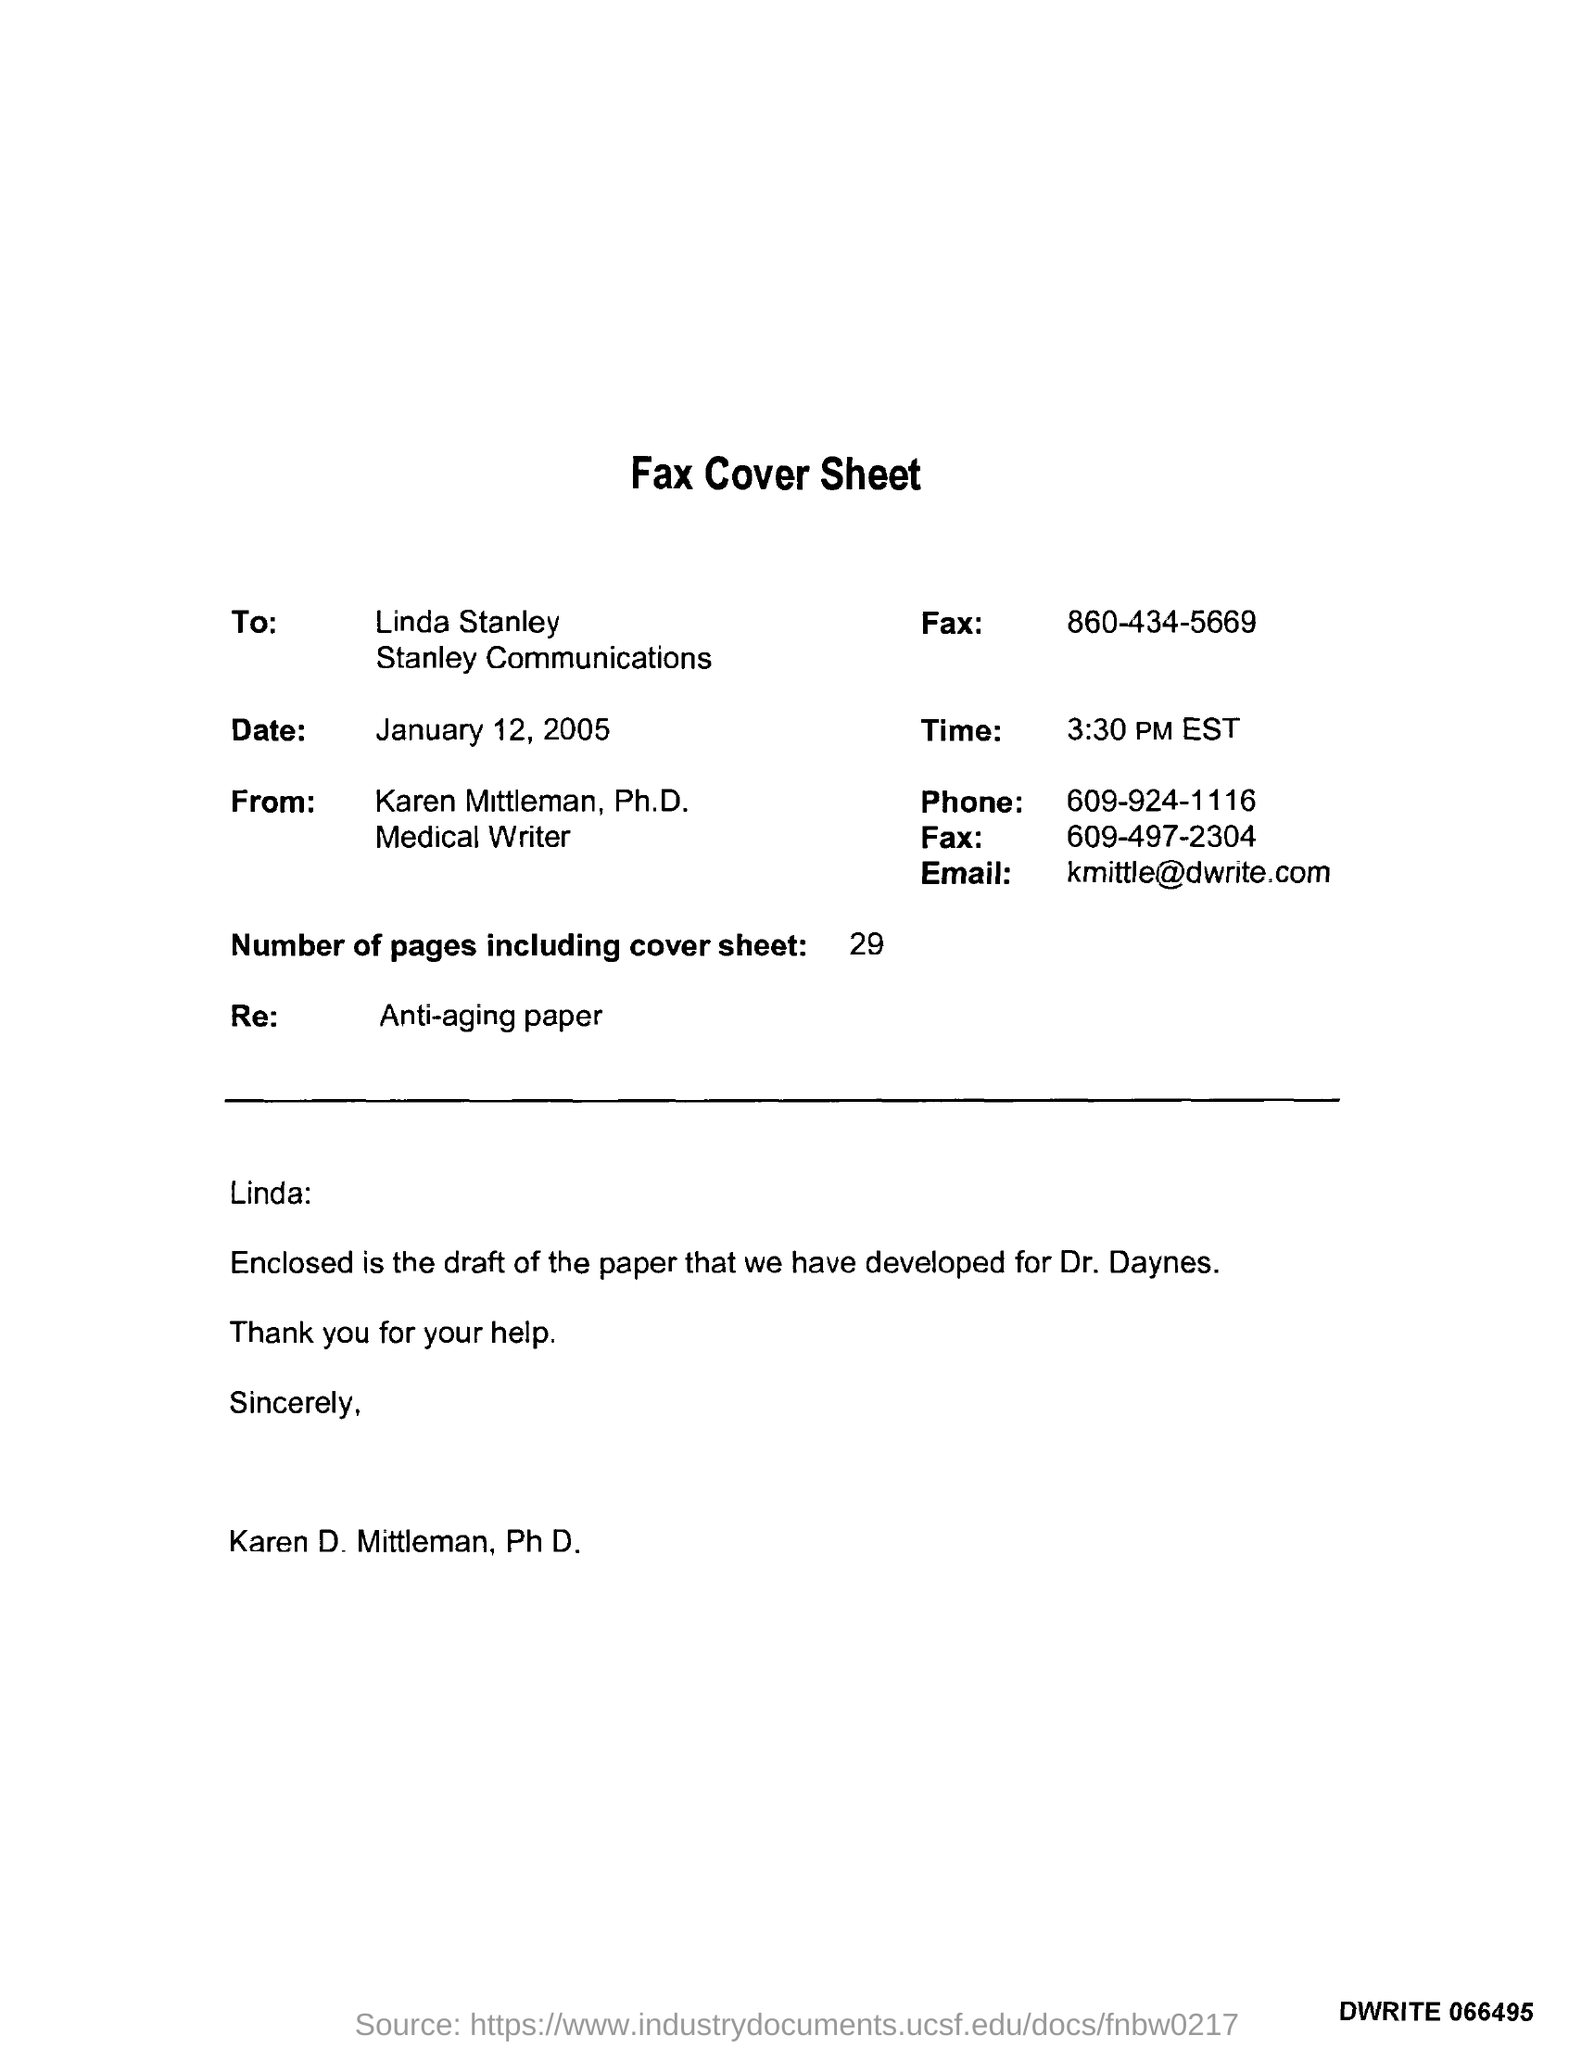To whom this letter was written ?
Your response must be concise. Linda stanley. What is the date mentioned in the fax cover sheet ?
Keep it short and to the point. January 12 , 2005. From whom this fax message was delivered ?
Offer a terse response. Karen mittleman, ph.d. What is the time mentioned in the given fax cover sheet?
Your answer should be compact. 3:30 pm EST. What is the phone number mentioned in the fax cover sheet?
Offer a terse response. 609-924-1116. How many number of pages are there including cover sheet ?
Your answer should be compact. 29. What is the re mentioned in the fax cover sheet ?
Offer a terse response. Anti-aging paper. 